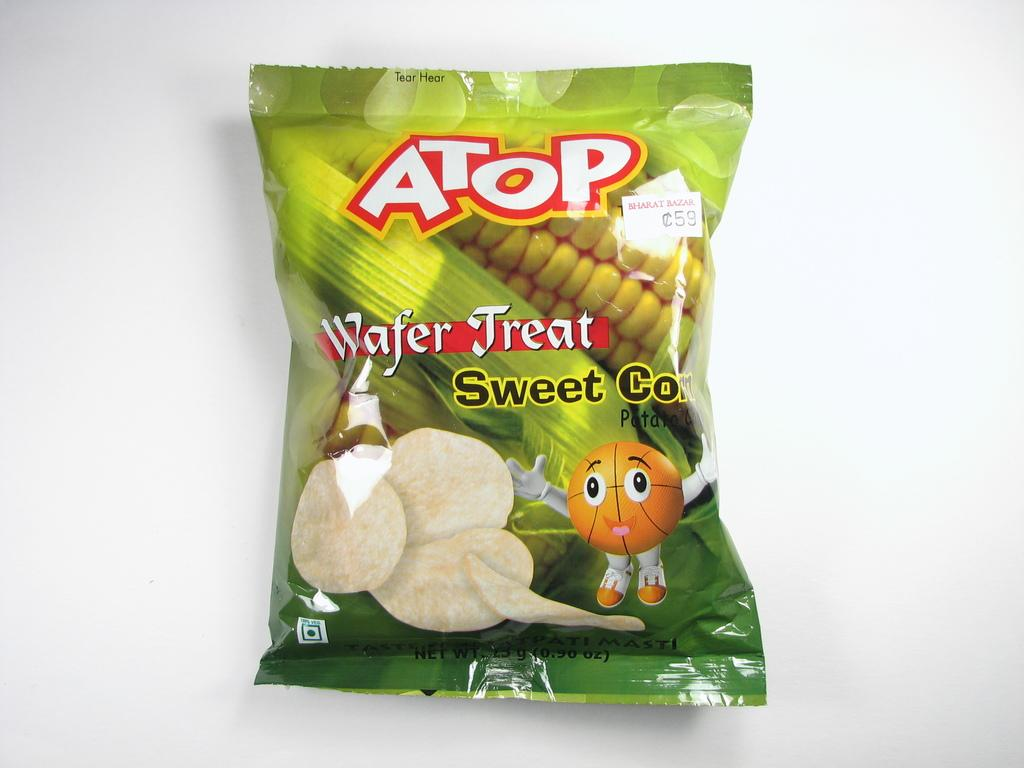What is the main object in the image? There is a food packet in the image. Where is the food packet located? The food packet is on a platform. What images can be seen on the food packet? The packet has pictures of a toy, chips, and maize. Is there any text on the food packet? Yes, there is text printed on the food packet. How many hands are visible helping to open the food packet in the image? There are no hands visible in the image, and the food packet is not being opened. 